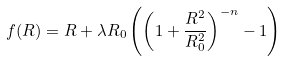<formula> <loc_0><loc_0><loc_500><loc_500>f ( R ) = R + \lambda R _ { 0 } \left ( \left ( 1 + \frac { R ^ { 2 } } { R _ { 0 } ^ { 2 } } \right ) ^ { - n } - 1 \right )</formula> 